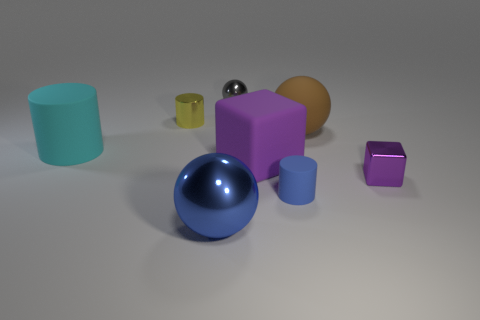What number of cylinders are small blue matte objects or blue metal things?
Provide a short and direct response. 1. The matte sphere has what color?
Give a very brief answer. Brown. Does the matte cylinder in front of the cyan matte cylinder have the same size as the purple rubber thing that is right of the big cylinder?
Your answer should be compact. No. Are there fewer small green matte cylinders than blue shiny things?
Provide a short and direct response. Yes. There is a large purple matte thing; how many metallic objects are in front of it?
Make the answer very short. 2. What is the small gray object made of?
Offer a very short reply. Metal. Does the big rubber block have the same color as the small metal cube?
Offer a terse response. Yes. Is the number of tiny yellow things right of the brown rubber ball less than the number of small gray cylinders?
Provide a succinct answer. No. The ball that is in front of the large cyan rubber cylinder is what color?
Offer a very short reply. Blue. What is the shape of the small gray metal thing?
Make the answer very short. Sphere. 